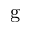Convert formula to latex. <formula><loc_0><loc_0><loc_500><loc_500>g</formula> 